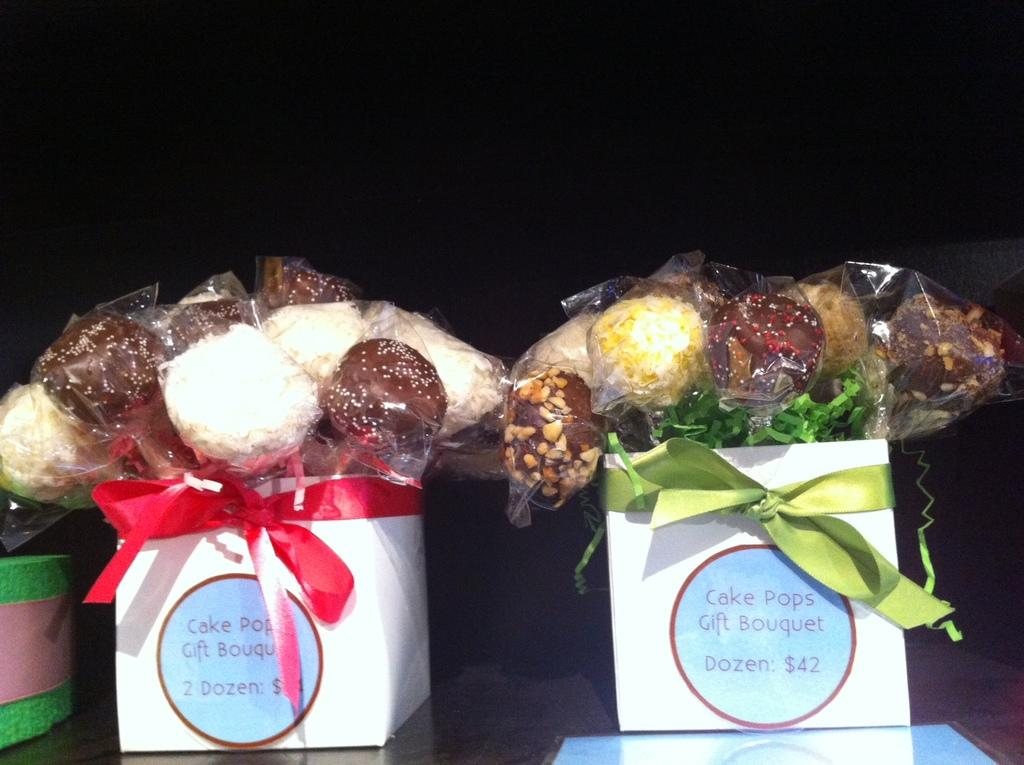What type of objects can be seen in the image? There are eatable things in the image. How are the eatable things arranged or organized? The eatable things are placed in boxes. What color is the hydrant in the middle of the image? There is no hydrant present in the image. Are there any cobwebs visible in the image? There is no mention of cobwebs in the provided facts, so we cannot determine if they are present in the image. 